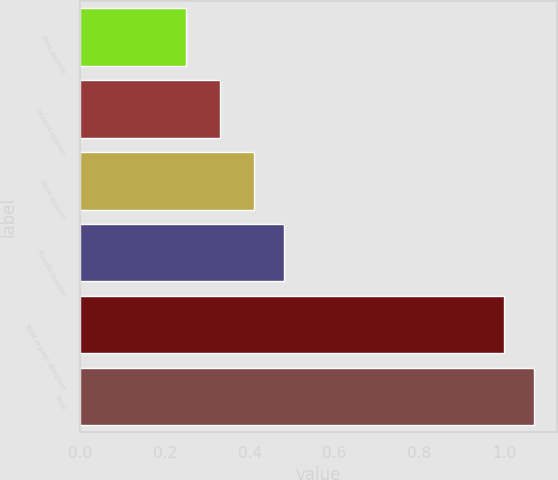<chart> <loc_0><loc_0><loc_500><loc_500><bar_chart><fcel>First quarter<fcel>Second quarter<fcel>Third quarter<fcel>Fourth quarter<fcel>Total regular dividend<fcel>Total<nl><fcel>0.25<fcel>0.33<fcel>0.41<fcel>0.48<fcel>1<fcel>1.07<nl></chart> 